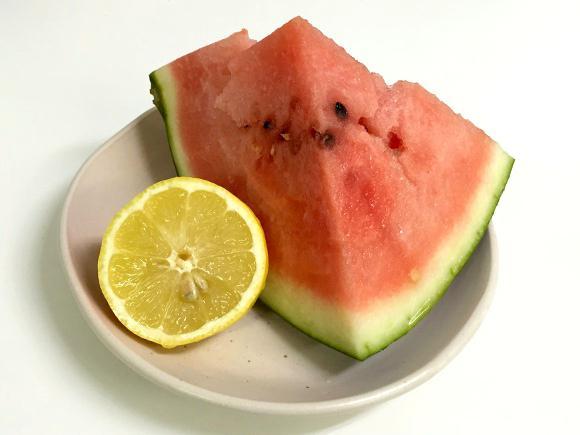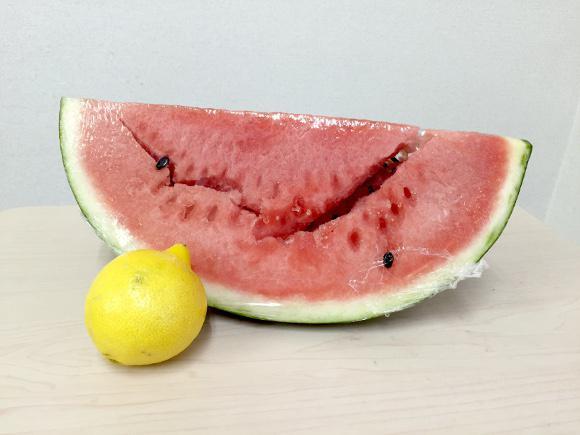The first image is the image on the left, the second image is the image on the right. For the images displayed, is the sentence "There is exactly one full lemon in the image on the right." factually correct? Answer yes or no. Yes. 